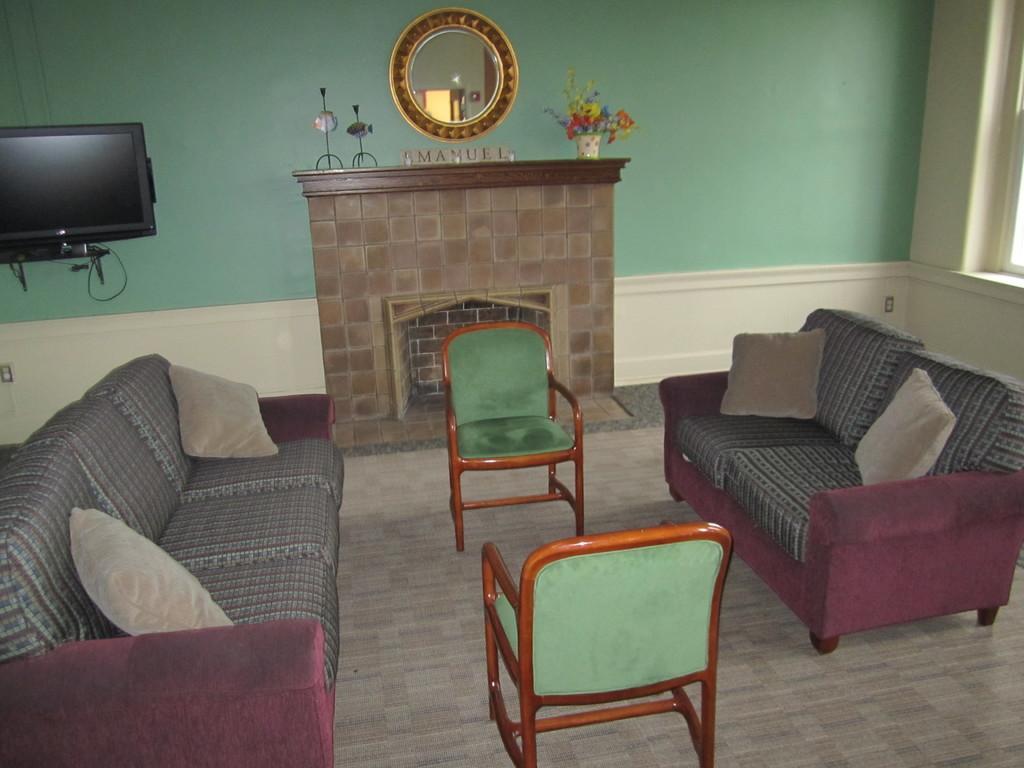Please provide a concise description of this image. in the room there is a sofa and in the center there are 2 chairs. at the back there is a mirror and at the left there is a t. v 